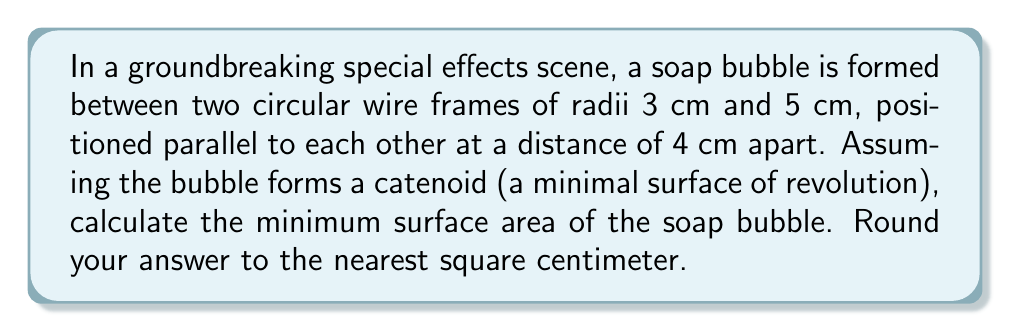Provide a solution to this math problem. Let's approach this step-by-step:

1) The surface of revolution of a catenary curve $y = a \cosh(\frac{x}{a})$ is called a catenoid. This is the shape our soap bubble will take.

2) We need to find the parameter $a$ that minimizes the surface area. The equation of the generating curve in our case is:

   $$y = a \cosh(\frac{x}{a})$$

3) At the boundary circles, we have:
   
   At $x = -2$: $3 = a \cosh(\frac{2}{a})$
   At $x = 2$:  $5 = a \cosh(\frac{2}{a})$

4) From these, we can derive:

   $$\frac{5}{3} = \frac{\cosh(\frac{2}{a})}{\cosh(\frac{-2}{a})} = \cosh(\frac{4}{a})$$

5) This gives us:

   $$a = \frac{4}{\text{arccosh}(\frac{5}{3})} \approx 3.42$$

6) The surface area of a catenoid is given by:

   $$A = 2\pi a^2 [\sinh(\frac{b}{a}) - \sinh(\frac{a}{a})]$$

   where $b$ is half the distance between the circles.

7) Substituting our values:

   $$A = 2\pi (3.42)^2 [\sinh(\frac{2}{3.42}) - \sinh(\frac{-2}{3.42})]$$

8) Calculating this:

   $$A \approx 146.3 \text{ cm}^2$$

9) Rounding to the nearest square centimeter:

   $$A \approx 146 \text{ cm}^2$$
Answer: 146 cm² 